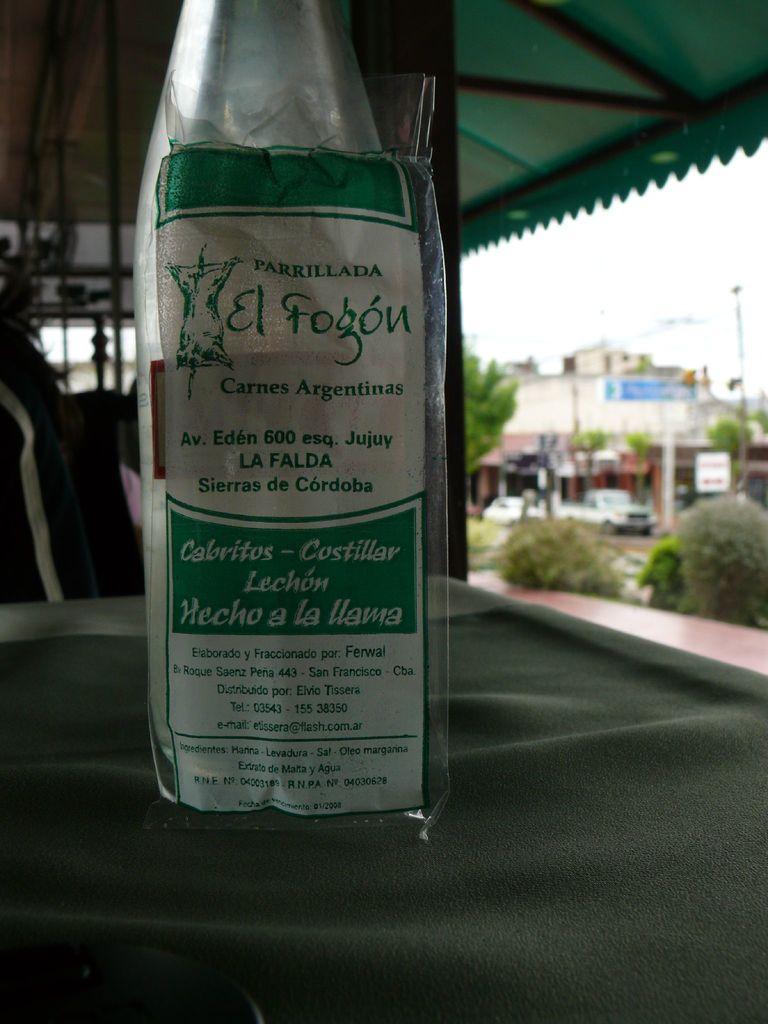What number is on the wine?
Keep it short and to the point. 600. 